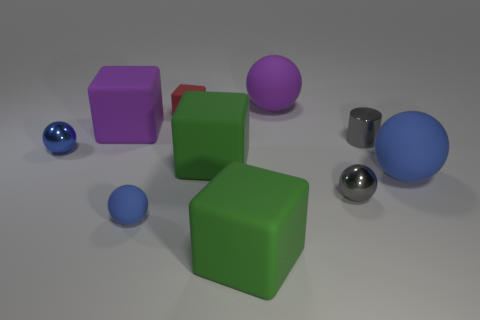Subtract all purple matte spheres. How many spheres are left? 4 Subtract all cylinders. How many objects are left? 9 Subtract all blue spheres. How many spheres are left? 2 Subtract all purple cylinders. Subtract all gray blocks. How many cylinders are left? 1 Subtract all green cylinders. How many green cubes are left? 2 Subtract 2 blue spheres. How many objects are left? 8 Subtract 5 spheres. How many spheres are left? 0 Subtract all blue metallic spheres. Subtract all large green blocks. How many objects are left? 7 Add 4 blue balls. How many blue balls are left? 7 Add 9 small cylinders. How many small cylinders exist? 10 